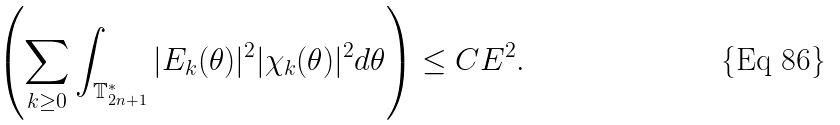Convert formula to latex. <formula><loc_0><loc_0><loc_500><loc_500>\left ( \sum _ { k \geq 0 } \int _ { \mathbb { T } ^ { * } _ { 2 n + 1 } } | E _ { k } ( \theta ) | ^ { 2 } | \chi _ { k } ( \theta ) | ^ { 2 } d \theta \right ) \leq C E ^ { 2 } .</formula> 